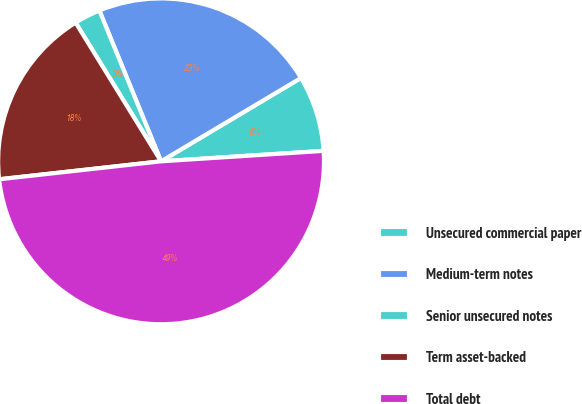<chart> <loc_0><loc_0><loc_500><loc_500><pie_chart><fcel>Unsecured commercial paper<fcel>Medium-term notes<fcel>Senior unsecured notes<fcel>Term asset-backed<fcel>Total debt<nl><fcel>7.53%<fcel>22.63%<fcel>2.61%<fcel>17.97%<fcel>49.26%<nl></chart> 